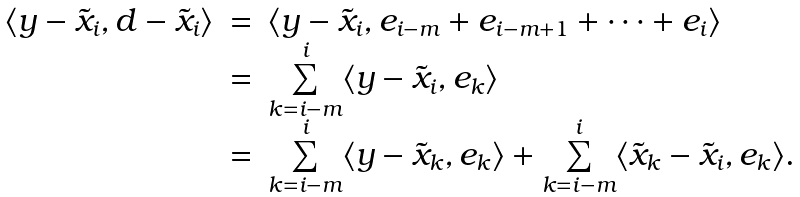Convert formula to latex. <formula><loc_0><loc_0><loc_500><loc_500>\begin{array} { r c l } \langle y - \tilde { x } _ { i } , d - \tilde { x } _ { i } \rangle & = & \langle y - \tilde { x } _ { i } , e _ { i - m } + e _ { i - m + 1 } + \cdots + e _ { i } \rangle \\ & = & \underset { k = i - m } { \overset { i } { \sum } } \langle y - \tilde { x } _ { i } , e _ { k } \rangle \\ & = & \underset { k = i - m } { \overset { i } { \sum } } \langle y - \tilde { x } _ { k } , e _ { k } \rangle + \underset { k = i - m } { \overset { i } { \sum } } \langle \tilde { x } _ { k } - \tilde { x } _ { i } , e _ { k } \rangle . \end{array}</formula> 